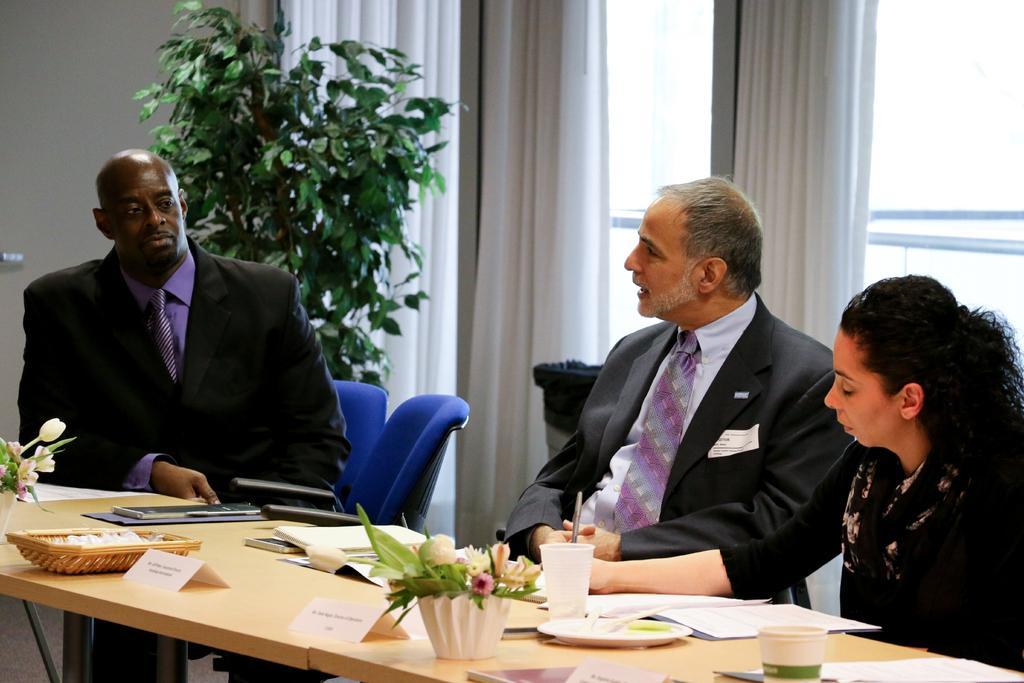Can you describe this image briefly? In this image I can see three people sitting in front of the table. On the table there is a flower vase,plate,cups and the papers. In the background there is a plant and the curtains to the window. 